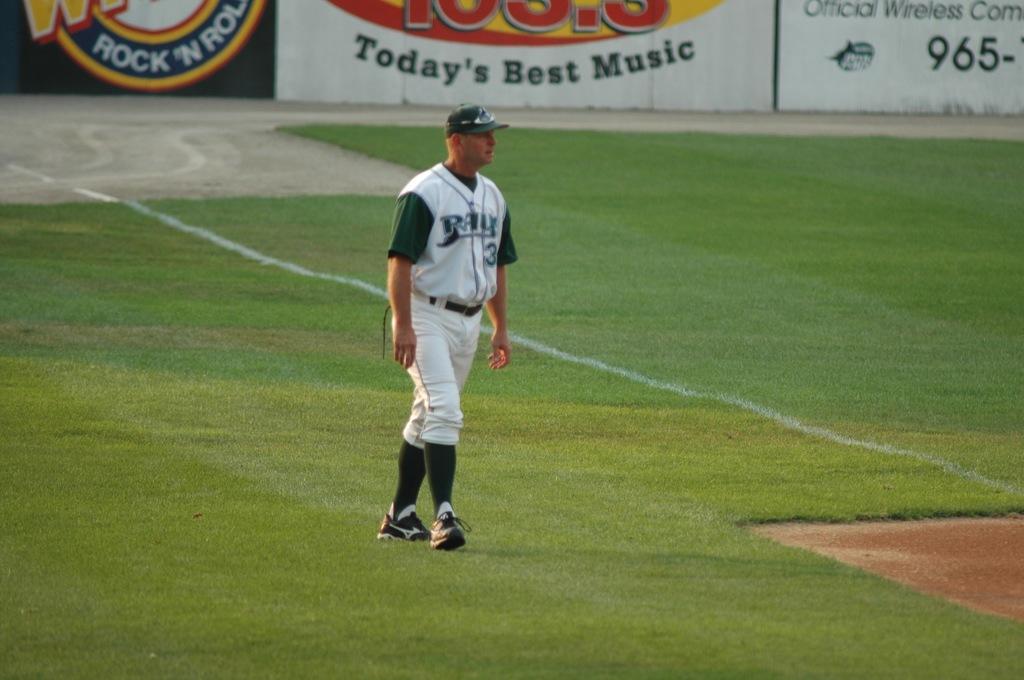What are the three numbers on the top right?
Provide a succinct answer. 965. What number is the player?
Give a very brief answer. 3. 